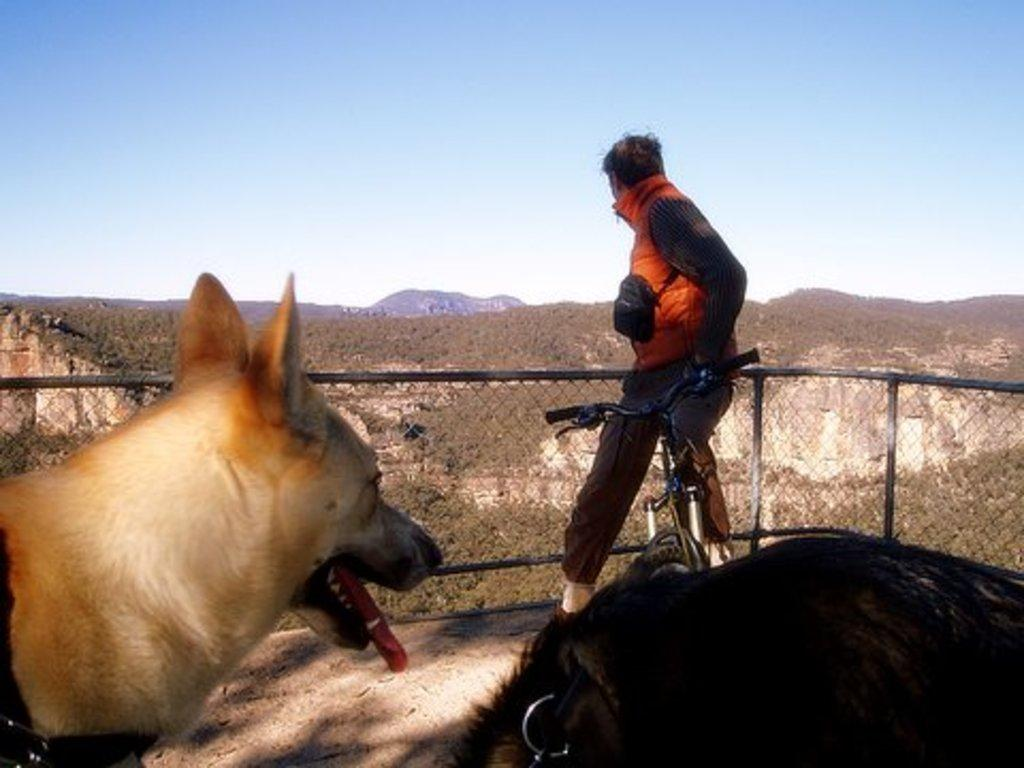What type of animal is at the bottom of the image? There is a dog at the bottom of the image. Can you describe the man's position in the image? A man is sitting on a bicycle at the fence. What can be seen in the background of the image? There are trees, mountains, and the sky visible in the background of the image. What type of orange is the queen holding in the image? There is no queen or orange present in the image. Where is the drawer located in the image? There is no drawer present in the image. 